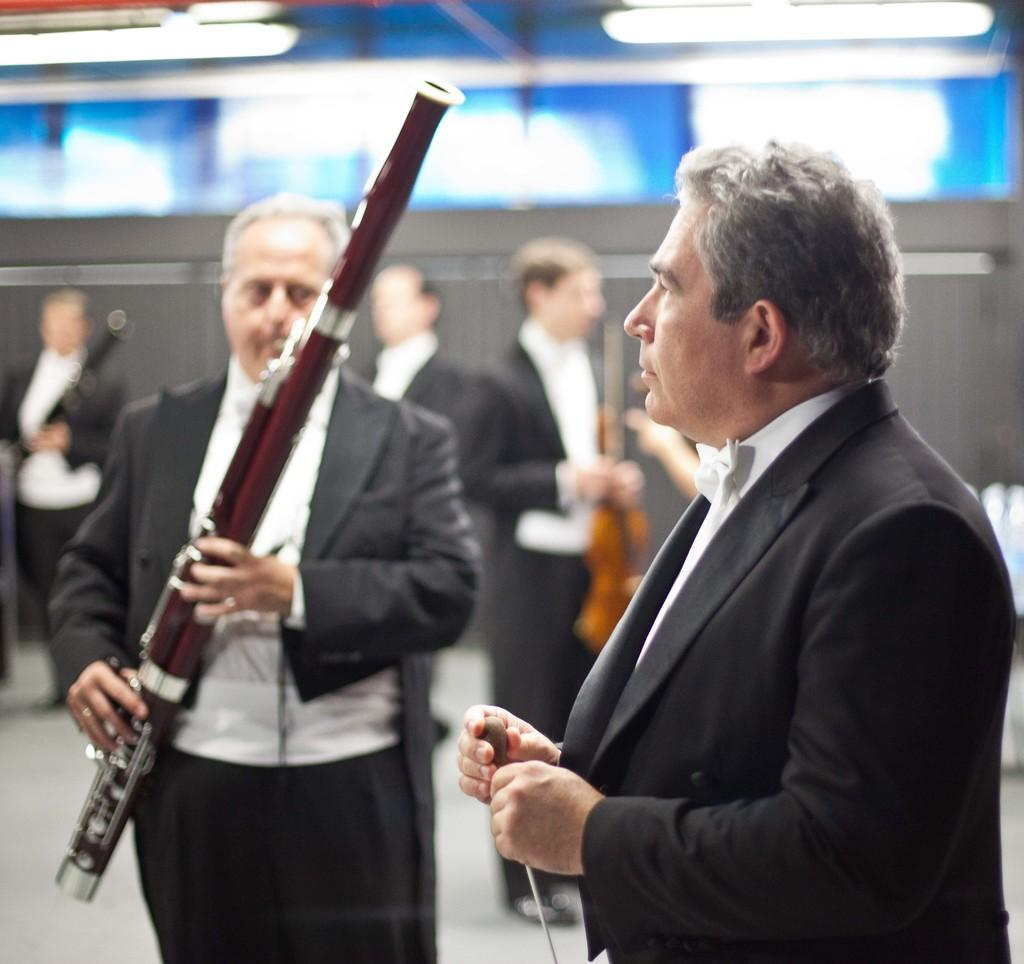What are the people in the image doing? The people in the image are standing and holding musical instruments. What types of musical instruments can be seen in the image? There are different types of musical instruments present in the image. Can you describe the people's actions in more detail? The people are likely playing or preparing to play their musical instruments. Is there a notebook visible on the stage in the image? There is no mention of a notebook or stage in the provided facts, so it cannot be determined if a notebook is present in the image. 